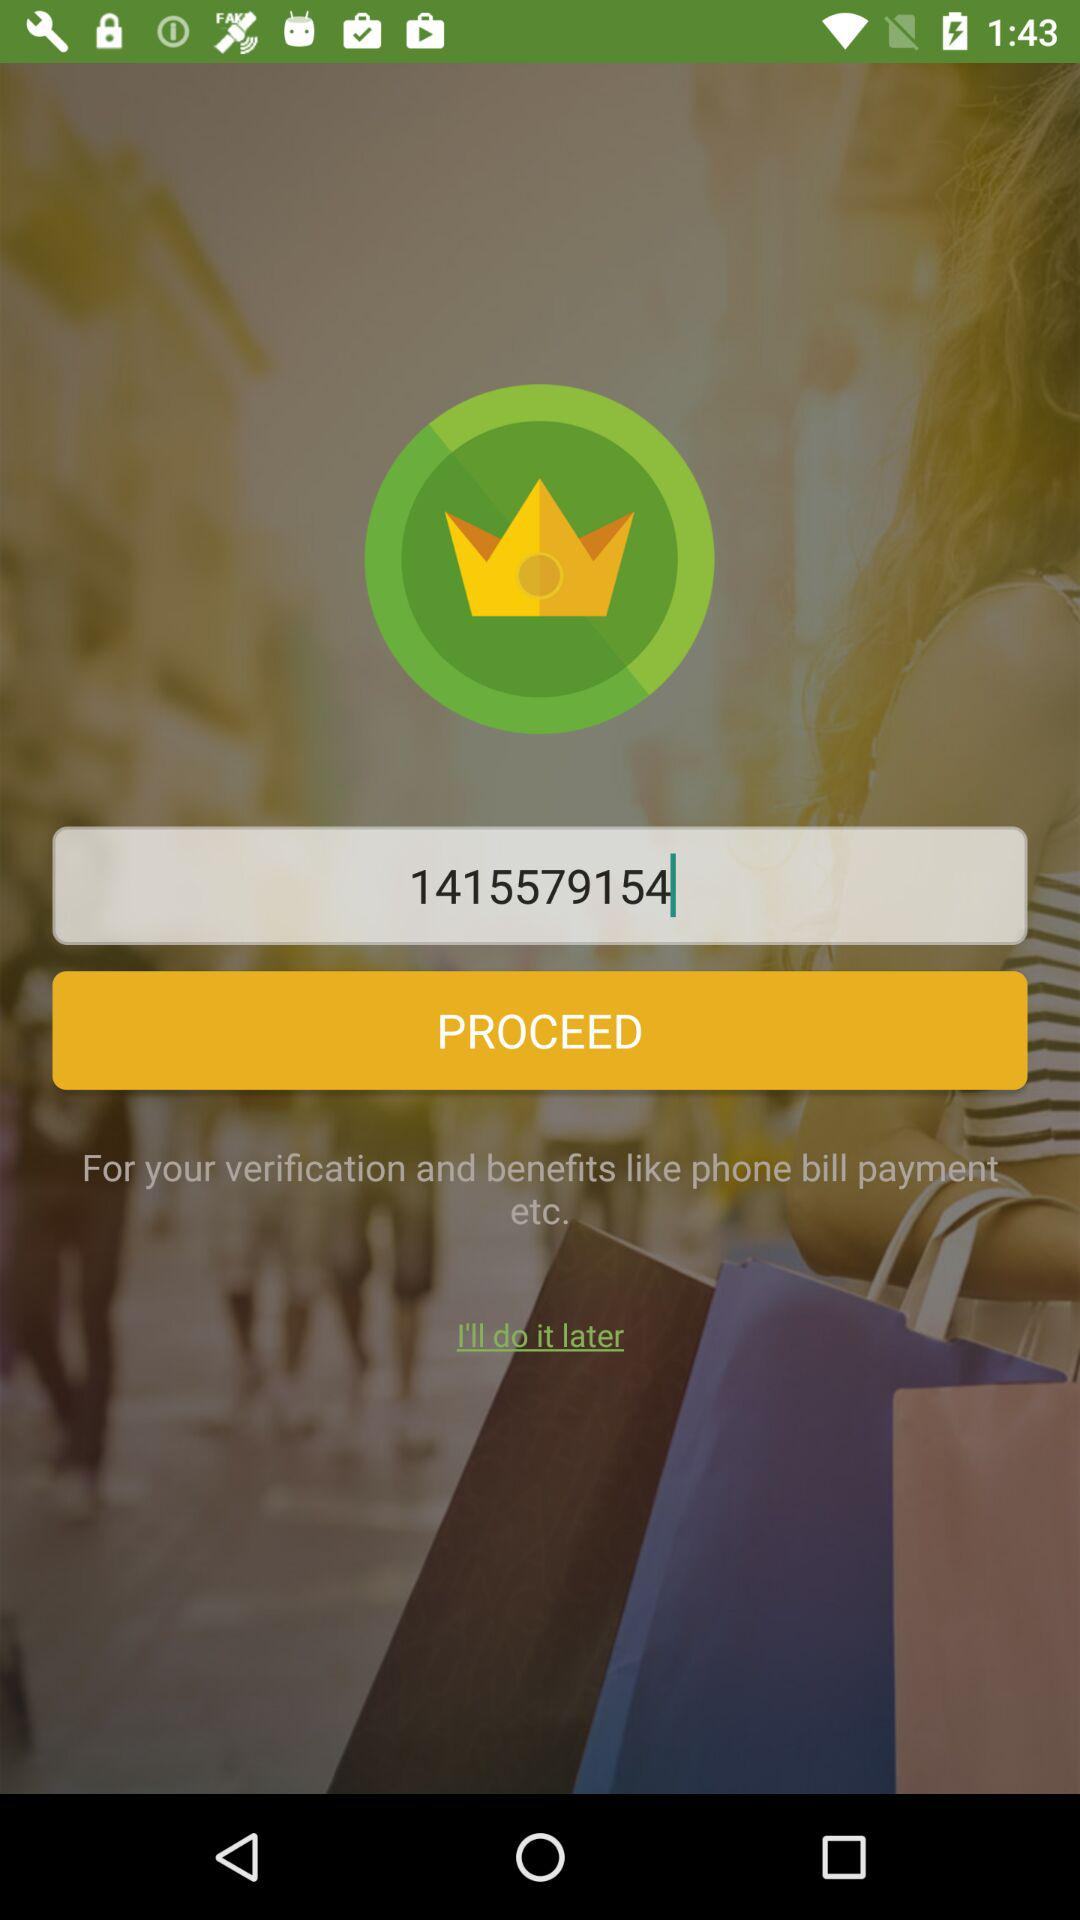What is the given verification code? The given verification code is 1415579154. 